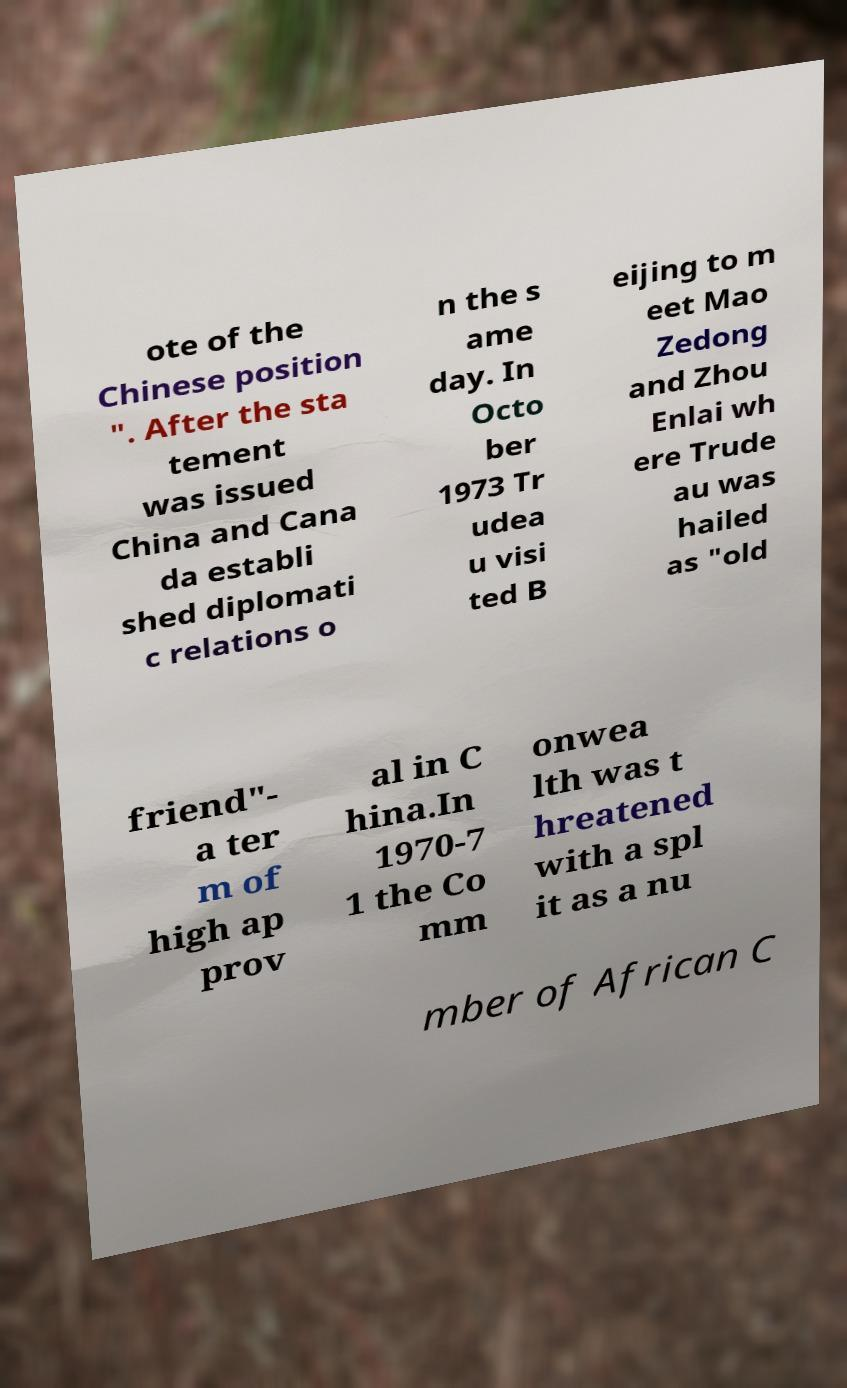Please read and relay the text visible in this image. What does it say? ote of the Chinese position ". After the sta tement was issued China and Cana da establi shed diplomati c relations o n the s ame day. In Octo ber 1973 Tr udea u visi ted B eijing to m eet Mao Zedong and Zhou Enlai wh ere Trude au was hailed as "old friend"- a ter m of high ap prov al in C hina.In 1970-7 1 the Co mm onwea lth was t hreatened with a spl it as a nu mber of African C 